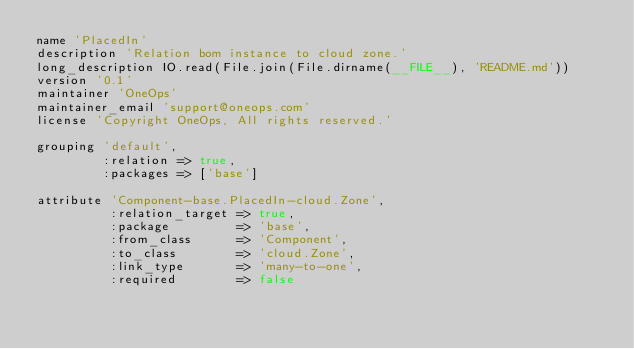<code> <loc_0><loc_0><loc_500><loc_500><_Ruby_>name 'PlacedIn'
description 'Relation bom instance to cloud zone.'
long_description IO.read(File.join(File.dirname(__FILE__), 'README.md'))
version '0.1'
maintainer 'OneOps'
maintainer_email 'support@oneops.com'
license 'Copyright OneOps, All rights reserved.'

grouping 'default',
         :relation => true,
         :packages => ['base']

attribute 'Component-base.PlacedIn-cloud.Zone',
          :relation_target => true,
          :package         => 'base',
          :from_class      => 'Component',
          :to_class        => 'cloud.Zone',
          :link_type       => 'many-to-one',
          :required        => false
</code> 